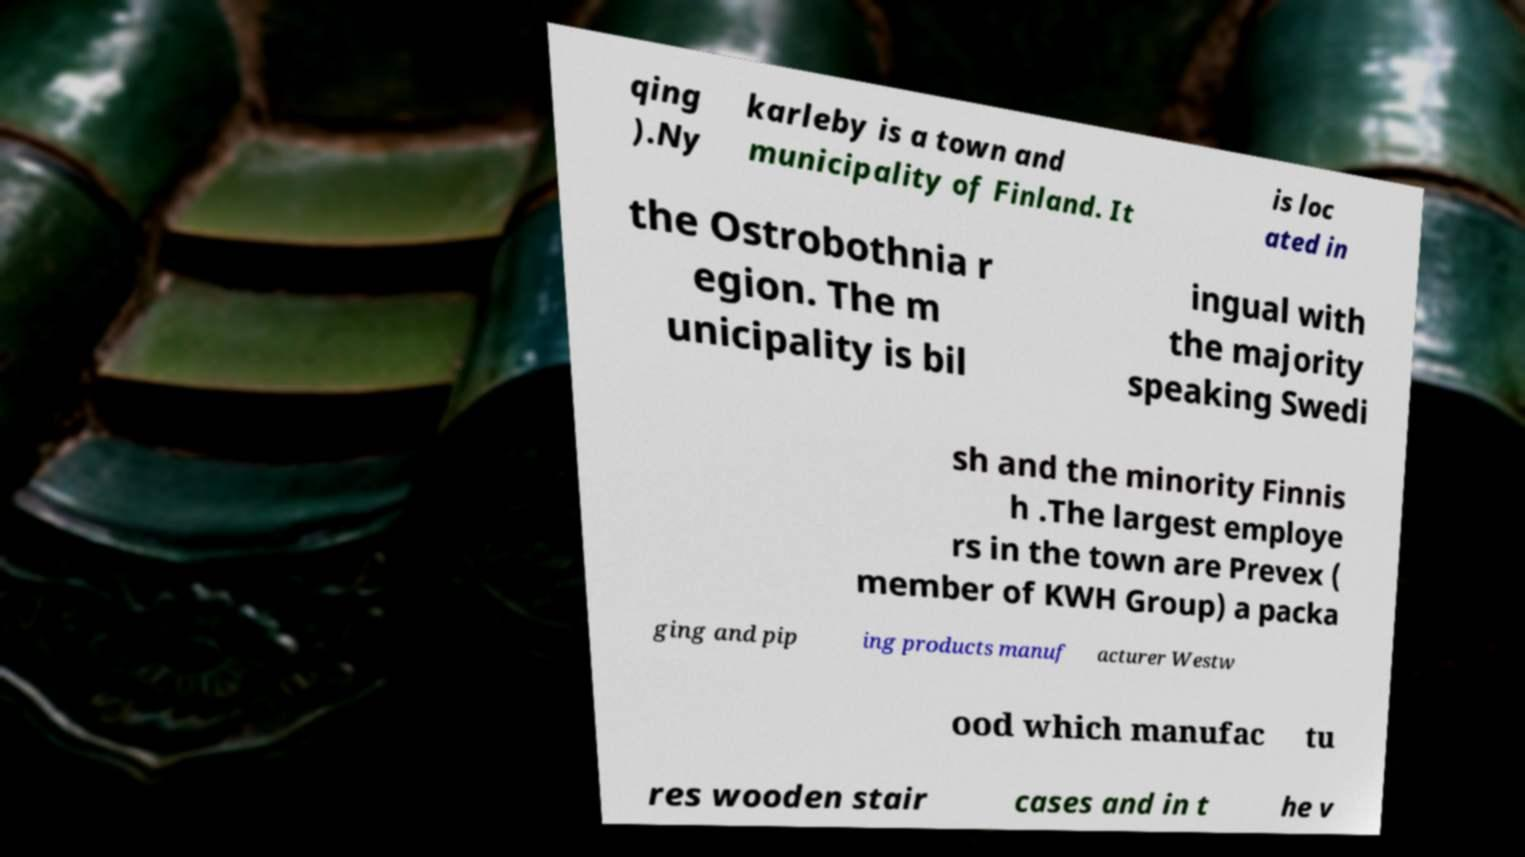Could you assist in decoding the text presented in this image and type it out clearly? qing ).Ny karleby is a town and municipality of Finland. It is loc ated in the Ostrobothnia r egion. The m unicipality is bil ingual with the majority speaking Swedi sh and the minority Finnis h .The largest employe rs in the town are Prevex ( member of KWH Group) a packa ging and pip ing products manuf acturer Westw ood which manufac tu res wooden stair cases and in t he v 